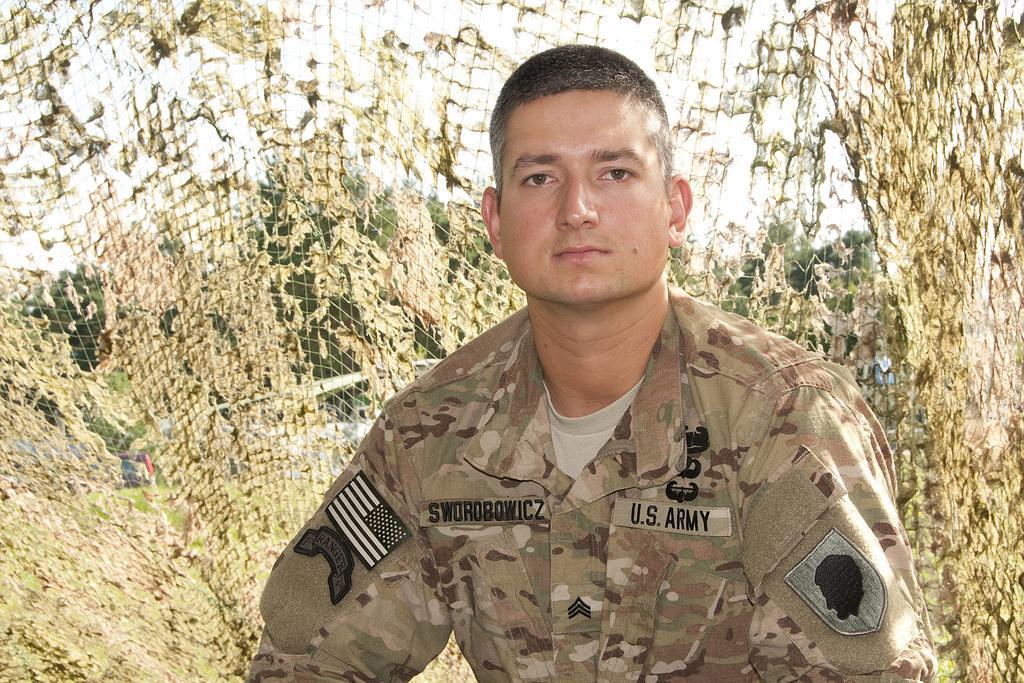Please provide a concise description of this image. In the image there is a man in camouflage dress standing in front of net, behind it there are trees on the grassland and above its sky. 